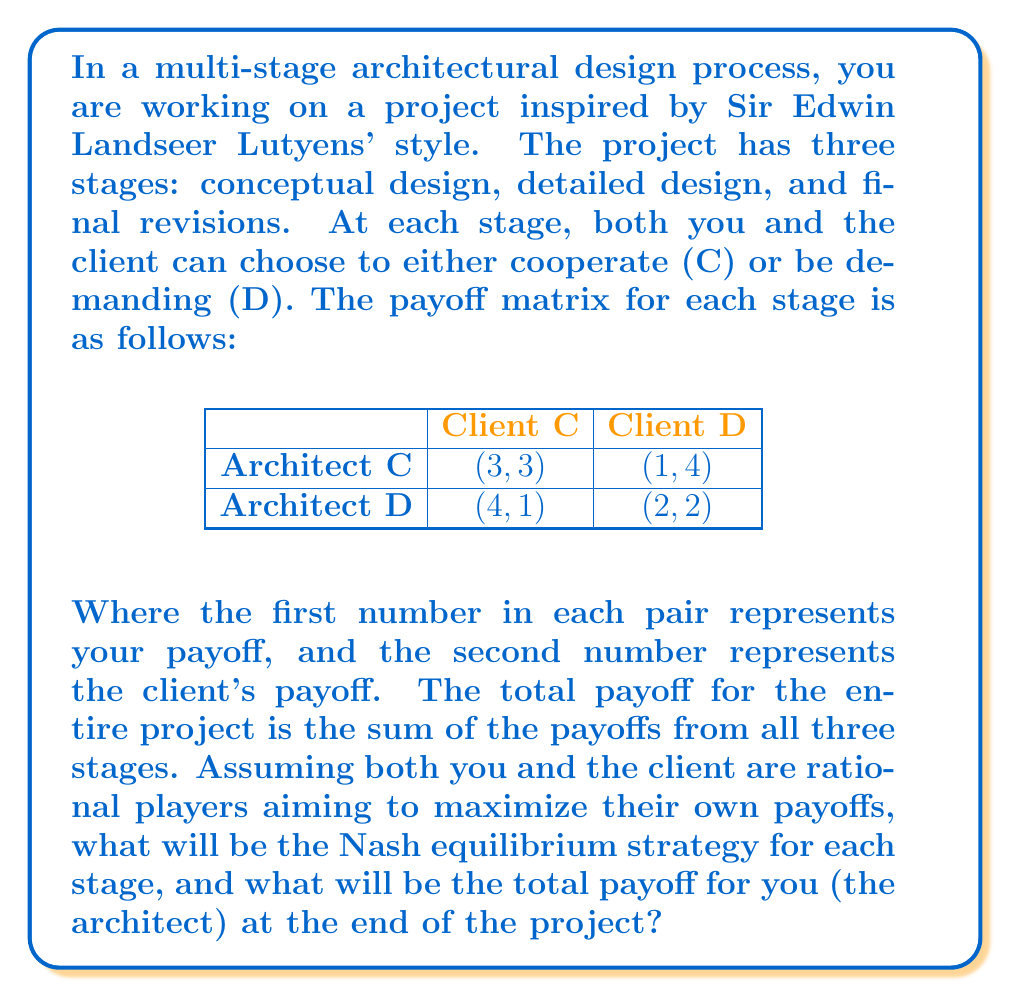Solve this math problem. To solve this problem, we need to analyze each stage of the game independently, as the payoff matrix is the same for all stages and there's no explicit connection between stages that would affect decision-making.

1. Analyzing a single stage:
   Let's first find the Nash equilibrium for a single stage. We can use the best response method:

   - If the client chooses C, the architect's best response is D (4 > 3)
   - If the client chooses D, the architect's best response is D (2 > 1)
   - If the architect chooses C, the client's best response is D (4 > 3)
   - If the architect chooses D, the client's best response is D (2 > 1)

   The Nash equilibrium for each stage is (D, D), resulting in a payoff of (2, 2).

2. Multi-stage analysis:
   Since the game is repeated for three stages and there's no incentive to deviate from the Nash equilibrium in any stage, the rational strategy for both players would be to play (D, D) in all three stages.

3. Calculating total payoff:
   The architect's payoff in each stage is 2, and there are three stages.
   Total payoff for the architect = $2 + 2 + 2 = 6$

Therefore, the Nash equilibrium strategy for each stage is (D, D), and the total payoff for the architect at the end of the project will be 6.
Answer: Nash equilibrium strategy for each stage: (D, D)
Total payoff for the architect: 6 